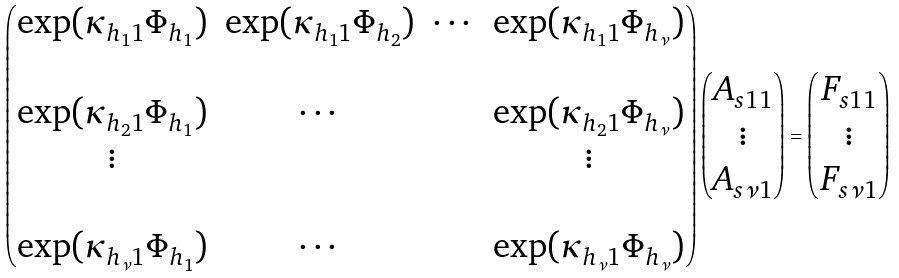Convert formula to latex. <formula><loc_0><loc_0><loc_500><loc_500>\begin{pmatrix} \exp ( \kappa _ { h _ { 1 } 1 } \Phi _ { h _ { 1 } } ) & \exp ( \kappa _ { h _ { 1 } 1 } \Phi _ { h _ { 2 } } ) & \cdots & \exp ( \kappa _ { h _ { 1 } 1 } \Phi _ { h _ { \nu } } ) \\ \\ \exp ( \kappa _ { h _ { 2 } 1 } \Phi _ { h _ { 1 } } ) & \cdots & & \exp ( \kappa _ { h _ { 2 } 1 } \Phi _ { h _ { \nu } } ) \\ \vdots & & & \vdots \\ \\ \exp ( \kappa _ { h _ { \nu } 1 } \Phi _ { h _ { 1 } } ) & \cdots & & \exp ( \kappa _ { h _ { \nu } 1 } \Phi _ { h _ { \nu } } ) \end{pmatrix} \begin{pmatrix} A _ { s 1 1 } \\ \vdots \\ A _ { s \nu 1 } \end{pmatrix} = \begin{pmatrix} F _ { s 1 1 } \\ \vdots \\ F _ { s \nu 1 } \end{pmatrix}</formula> 